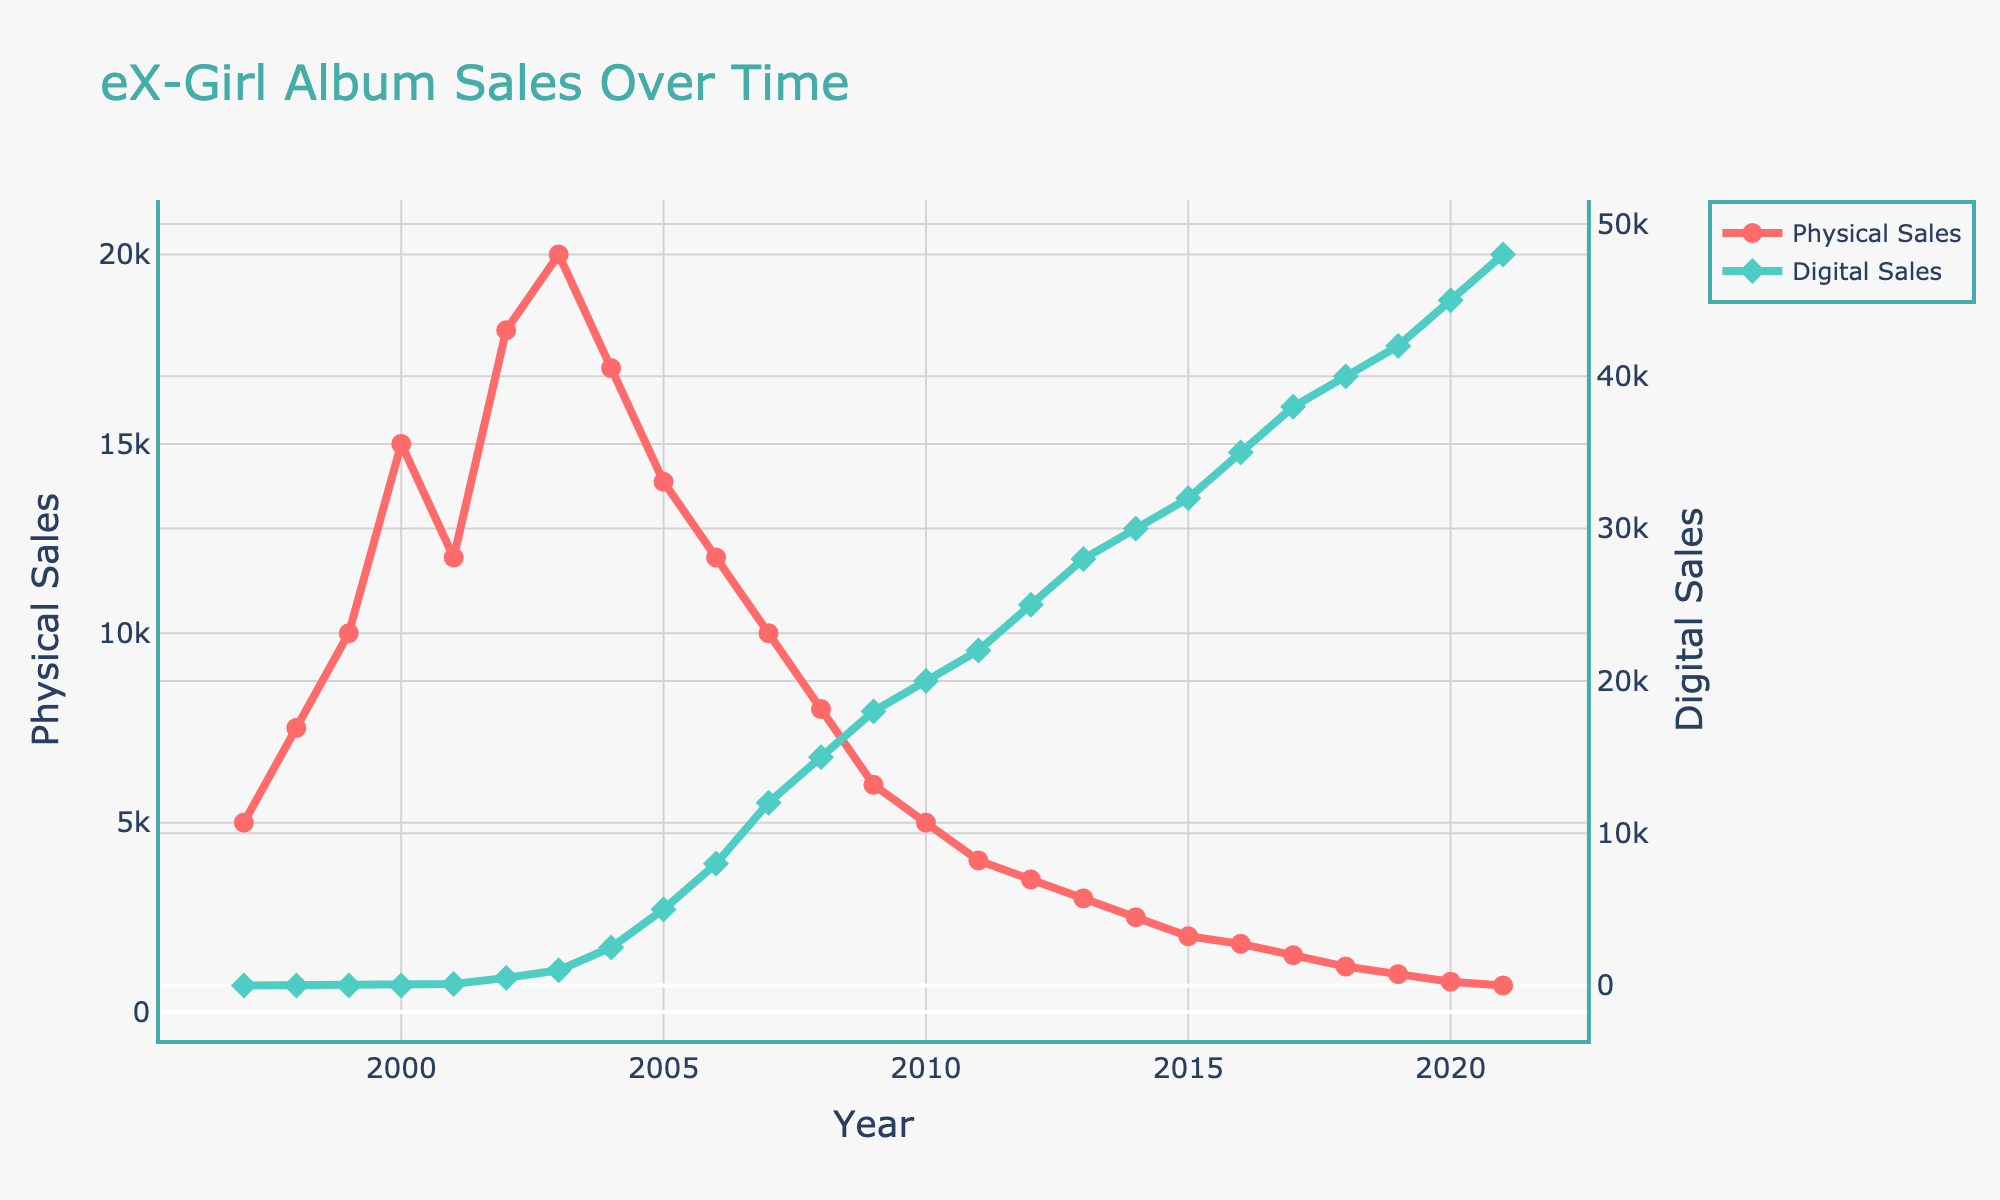What year did digital sales first appear, and what was the value? Digital sales first appeared when the line representing digital sales intersects the y-axis for the first time. This occurs in the year 2001 with a value of 100.
Answer: 2001, 100 What is the maximum value of physical sales and in which year did it occur? The highest point on the line representing physical sales indicates the maximum value. This occurs in the year 2003 with a value of 20000.
Answer: 2003, 20000 In which year did digital sales surpass physical sales? Look for the point where the line for digital sales crosses above the line for physical sales. This happens in the year 2007.
Answer: 2007 What is the total sales (physical + digital) for the year 2009? Sum the values of physical and digital sales for 2009. Physical sales are 6000 and digital sales are 18000, so the total is 6000 + 18000 = 24000.
Answer: 24000 Which year experienced the largest decline in physical sales from the previous year, and what is the value of the decline? Calculate the difference in physical sales year by year and identify the largest one. The largest decline happened between 2004 (17000) and 2005 (14000), giving a decline of 17000 - 14000 = 3000.
Answer: 2005, 3000 What are the values of physical and digital sales in 2010? Refer to the corresponding points on the graph for the year 2010. Physical sales are 5000 and digital sales are 20000.
Answer: 5000, 20000 Which sales type (physical or digital) shows a more stable trend over the years, and how can you tell? Compare the volatility of the two lines. The physical sales line shows a more consistent decline, whereas digital sales show a steady increase. Hence, digital sales are more stable.
Answer: Digital What is the average annual increase in digital sales from 2001 to 2021? Calculate the total increase (48000 in 2021 - 100 in 2001 = 47900) and divide by the number of years (2021 - 2001 = 20). The average annual increase is 47900 / 20 = 2395.
Answer: 2395 How many years did it take for digital sales to reach 10000 after they first appeared? Digital sales appeared in 2001 and reached 10000 in 2007. Therefore, it took 2007 - 2001 = 6 years.
Answer: 6 What is the trend of physical sales after the year 2010? Observe the line representing physical sales after the 2010 mark. The trend shows a continuous decline.
Answer: Decline 